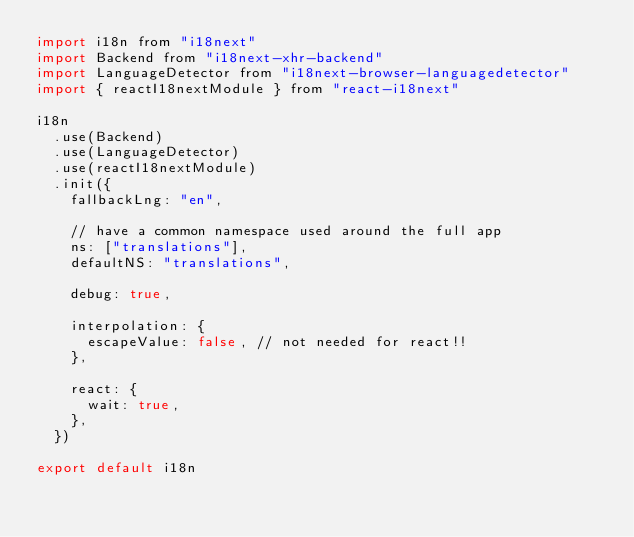Convert code to text. <code><loc_0><loc_0><loc_500><loc_500><_JavaScript_>import i18n from "i18next"
import Backend from "i18next-xhr-backend"
import LanguageDetector from "i18next-browser-languagedetector"
import { reactI18nextModule } from "react-i18next"

i18n
  .use(Backend)
  .use(LanguageDetector)
  .use(reactI18nextModule)
  .init({
    fallbackLng: "en",

    // have a common namespace used around the full app
    ns: ["translations"],
    defaultNS: "translations",

    debug: true,

    interpolation: {
      escapeValue: false, // not needed for react!!
    },

    react: {
      wait: true,
    },
  })

export default i18n
</code> 